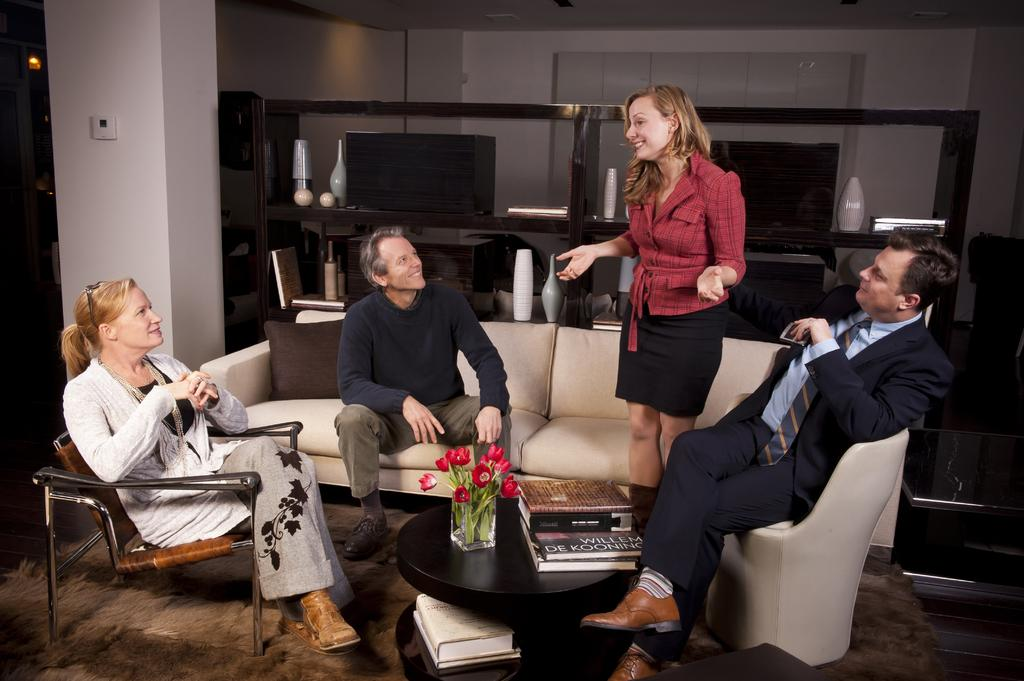What type of furniture is in the image? There is a sofa in the image. Who is sitting on the sofa? A person is sitting on the sofa. What other piece of furniture is in the image? There is a table in the image. What is the woman in the image doing? A woman is standing in the image. Can you describe the seating arrangement of the other woman? Another woman is sitting on a chair in the image. What can be seen in the background of the image? There is a pillar in the background of the image. What object in the image might be used for turning on or off a light? There is a switch in the image. What decorative item is present in the image? There is a vase in the image. What type of fight is taking place between the two women in the image? There is no fight taking place between the two women in the image. What type of spade is being used by the person sitting on the sofa? There is no spade present in the image. What type of underwear is the person sitting on the sofa wearing? There is no information about the person's underwear in the image. 